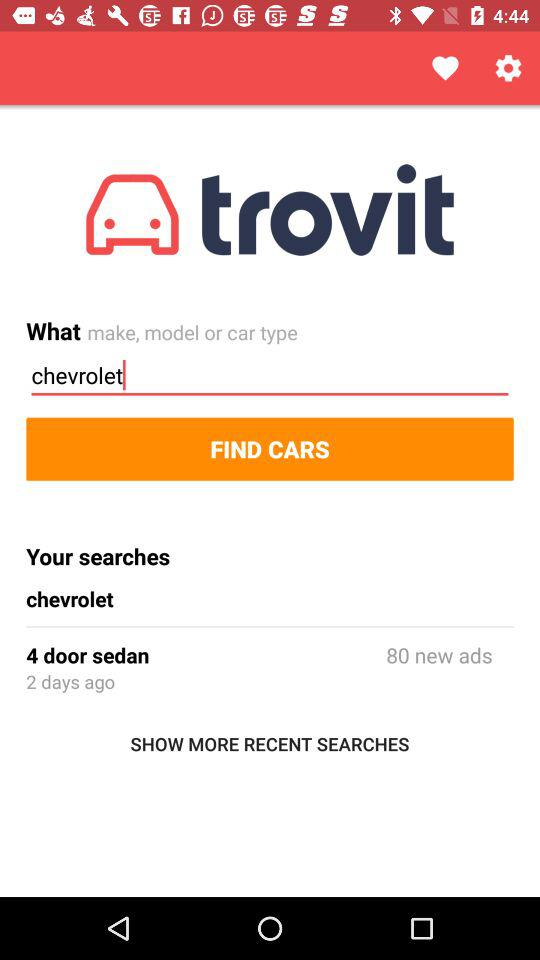What is the application name? The application name is "trovit". 